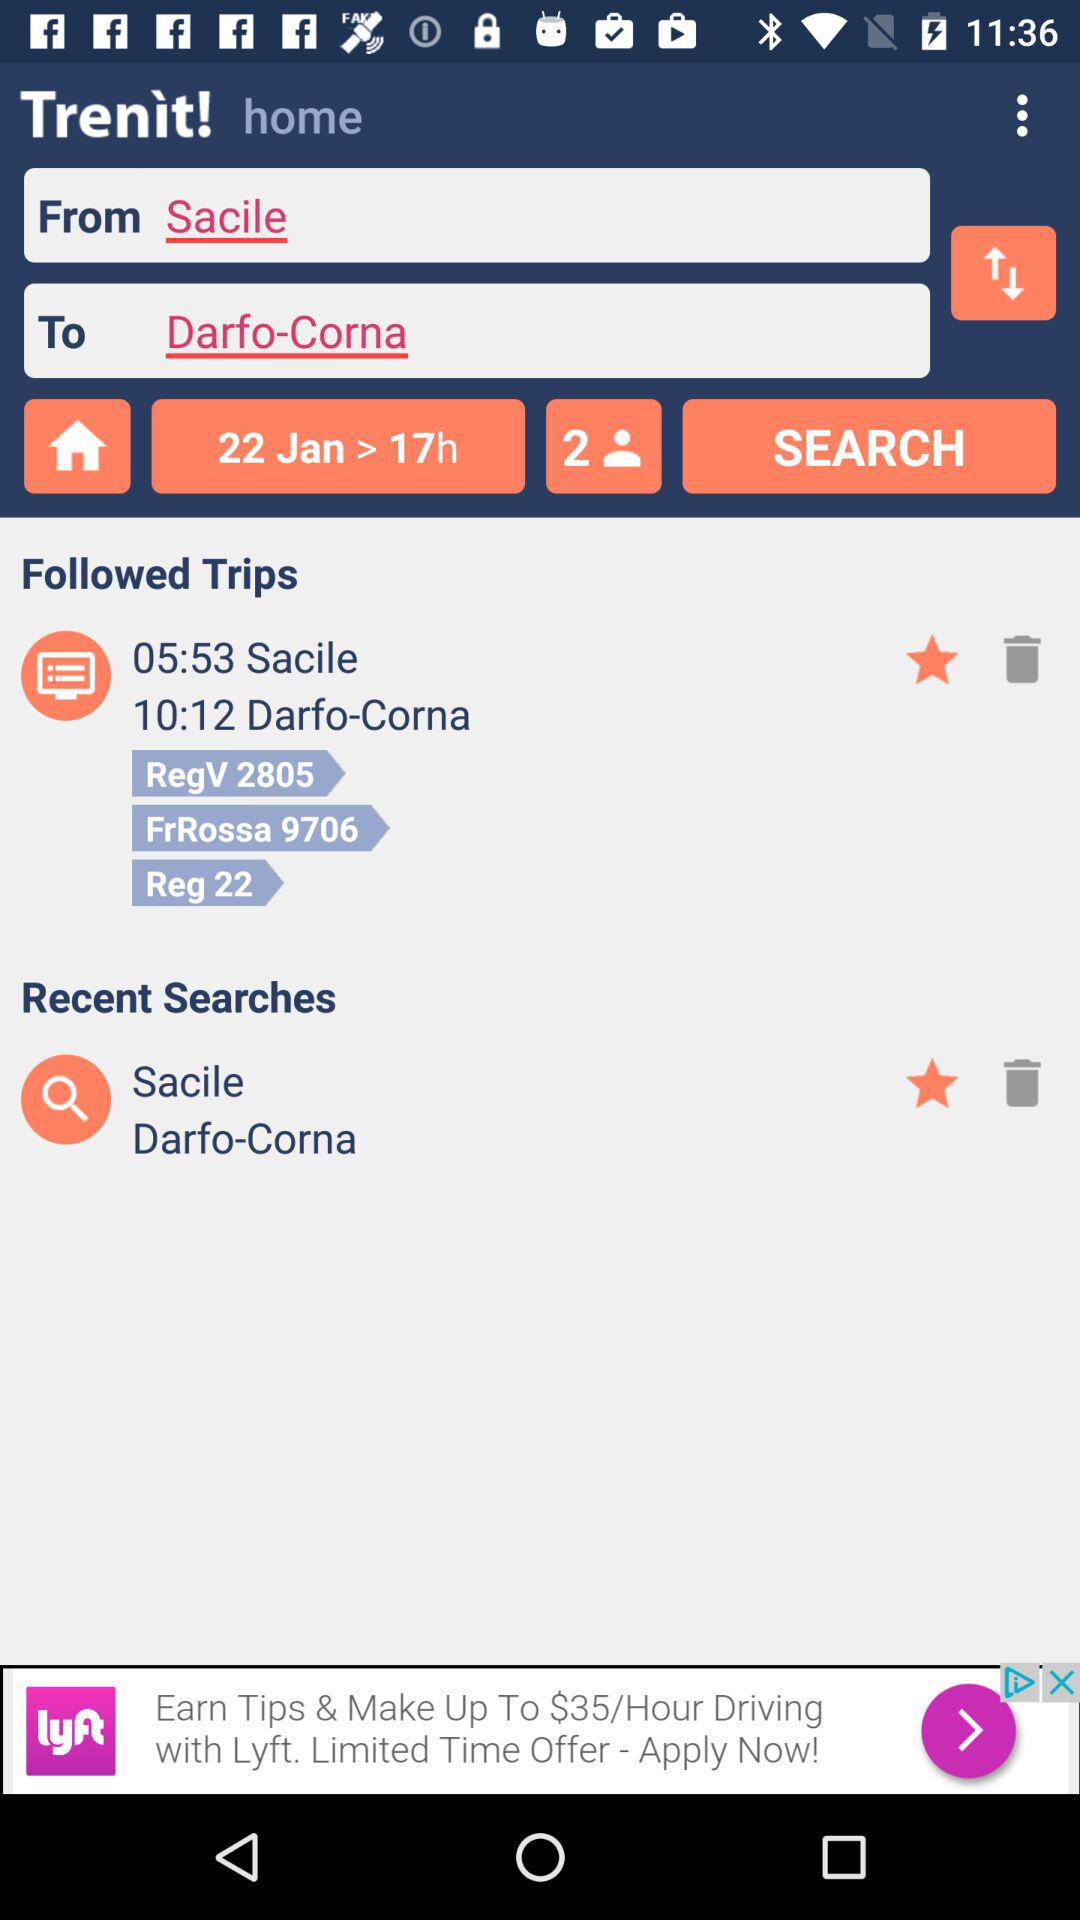Which location is selected in "From"? The location selected in "From" is Sacile. 